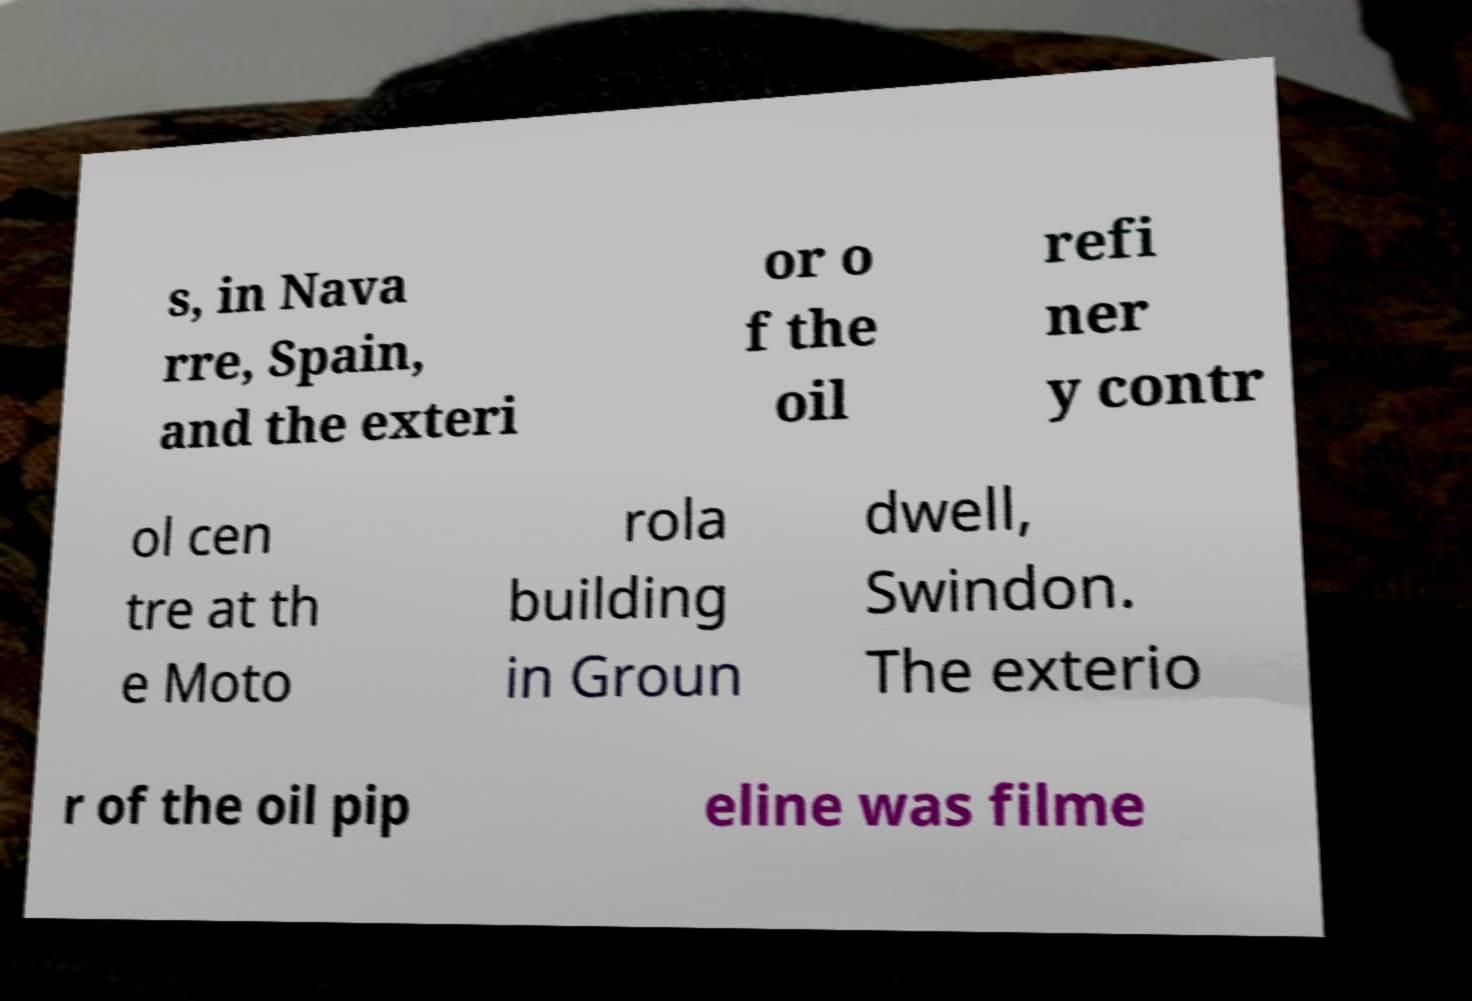For documentation purposes, I need the text within this image transcribed. Could you provide that? s, in Nava rre, Spain, and the exteri or o f the oil refi ner y contr ol cen tre at th e Moto rola building in Groun dwell, Swindon. The exterio r of the oil pip eline was filme 